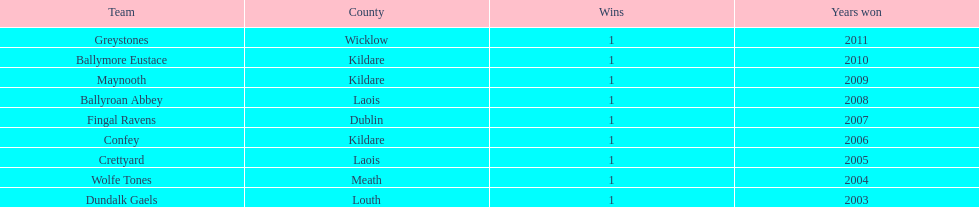What is the number of wins for each team 1. 